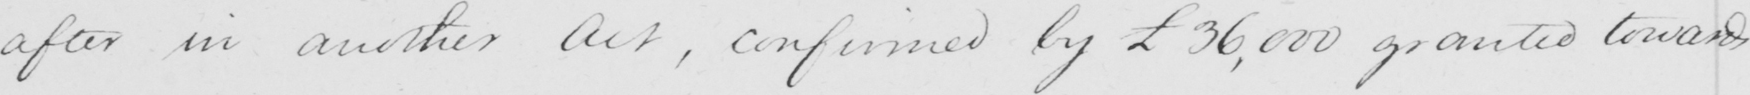Please provide the text content of this handwritten line. after in another Act , confirmed by £36.000 granted towards 